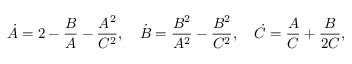<formula> <loc_0><loc_0><loc_500><loc_500>\dot { A } = 2 - \frac { B } { A } - \frac { A ^ { 2 } } { C ^ { 2 } } , \quad \dot { B } = \frac { B ^ { 2 } } { A ^ { 2 } } - \frac { B ^ { 2 } } { C ^ { 2 } } , \quad \dot { C } = \frac { A } { C } + \frac { B } { 2 C } ,</formula> 